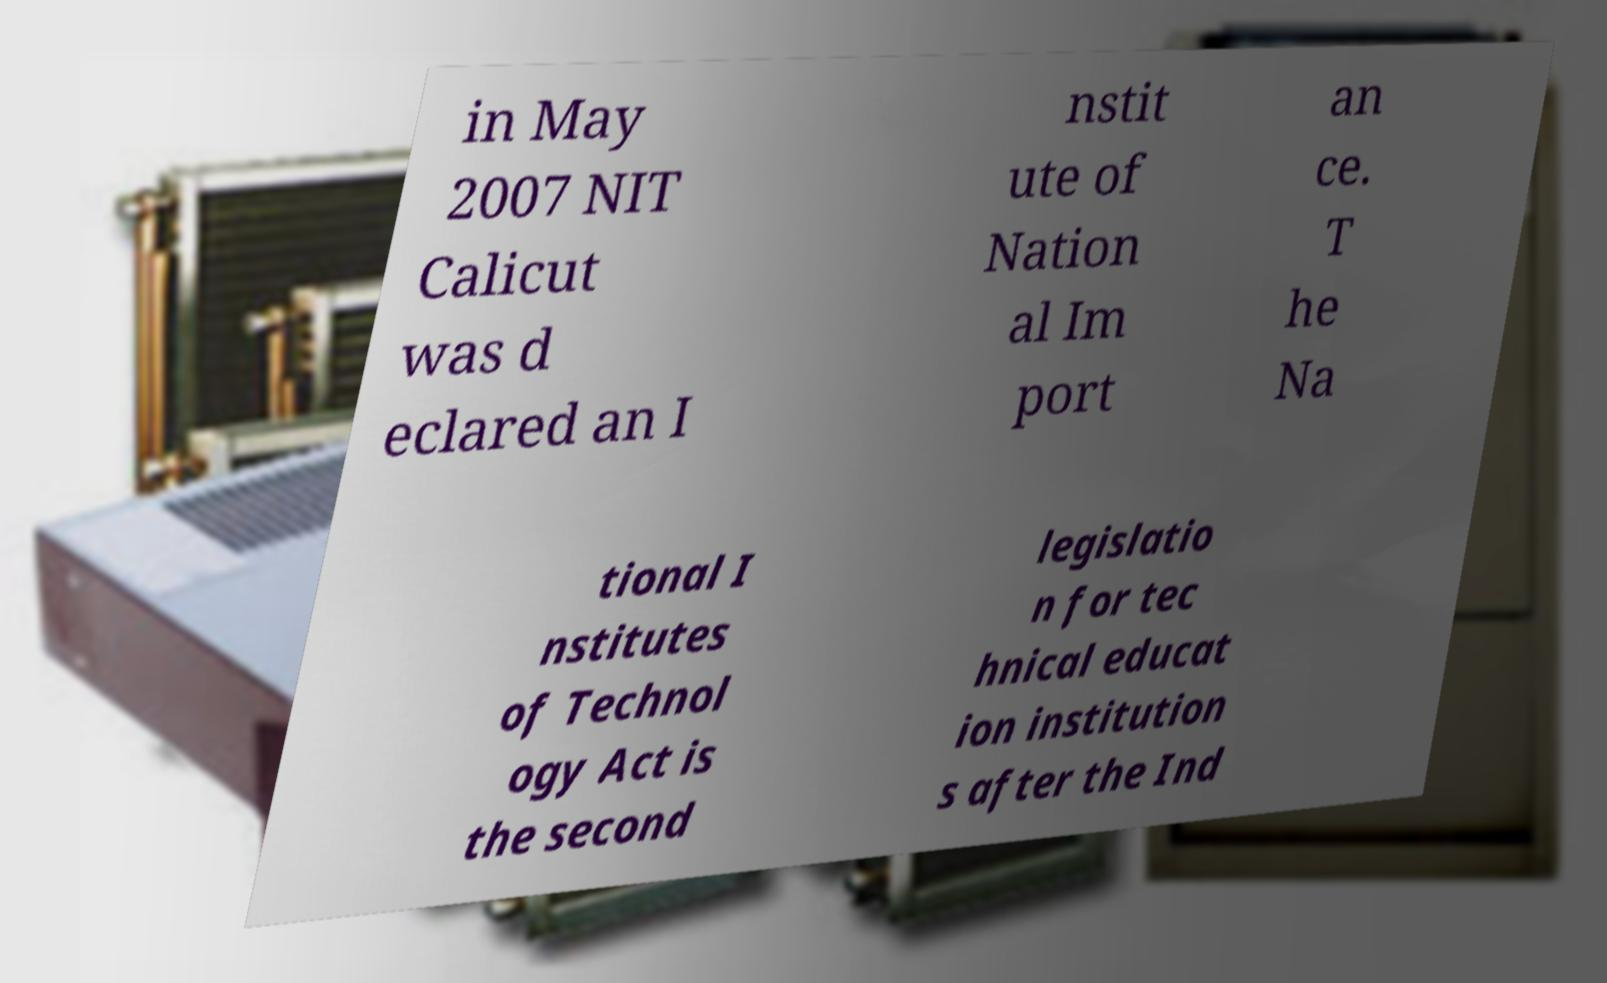Could you assist in decoding the text presented in this image and type it out clearly? in May 2007 NIT Calicut was d eclared an I nstit ute of Nation al Im port an ce. T he Na tional I nstitutes of Technol ogy Act is the second legislatio n for tec hnical educat ion institution s after the Ind 